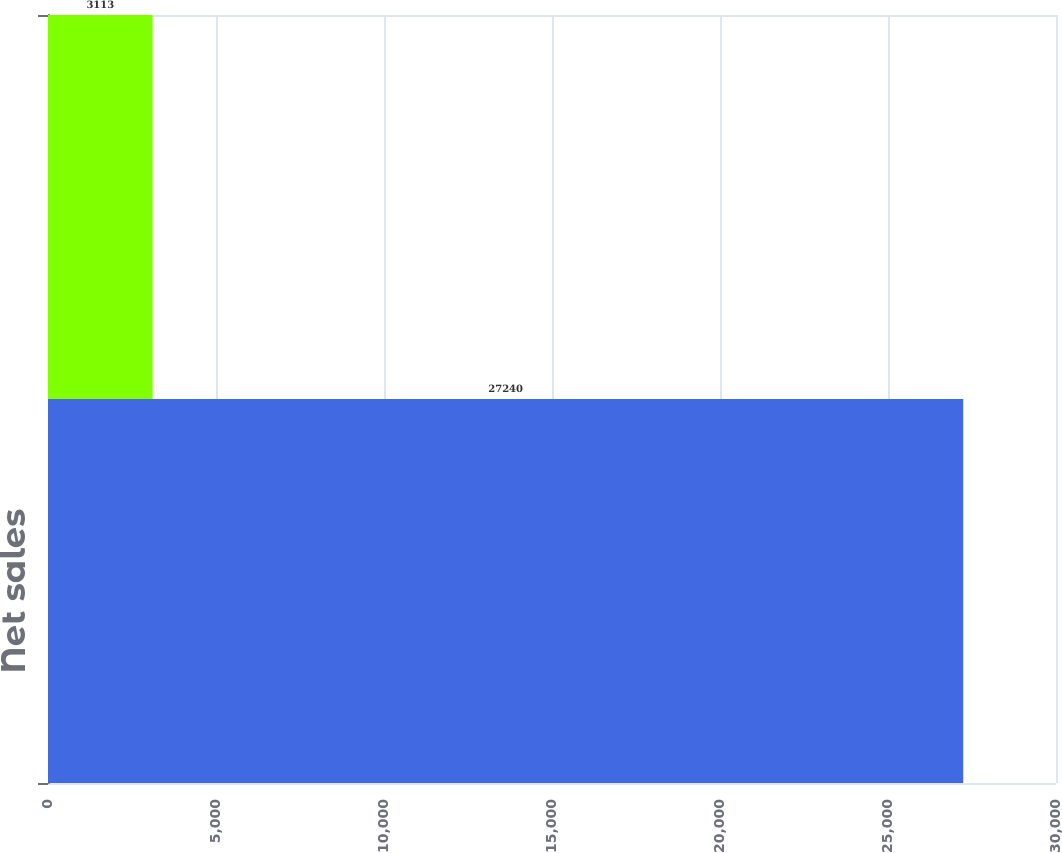Convert chart. <chart><loc_0><loc_0><loc_500><loc_500><bar_chart><fcel>Net sales<fcel>Operating earnings<nl><fcel>27240<fcel>3113<nl></chart> 